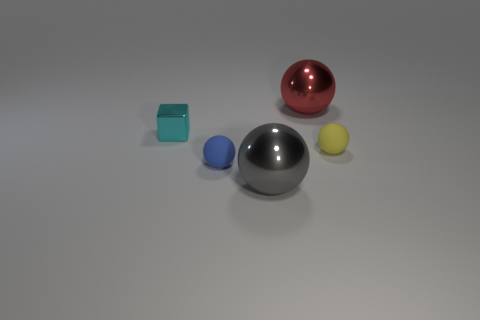Subtract all gray metal spheres. How many spheres are left? 3 Add 1 tiny metal things. How many objects exist? 6 Subtract all yellow spheres. How many spheres are left? 3 Subtract 1 balls. How many balls are left? 3 Subtract all balls. How many objects are left? 1 Subtract all green spheres. Subtract all gray blocks. How many spheres are left? 4 Add 3 red things. How many red things exist? 4 Subtract 0 green balls. How many objects are left? 5 Subtract all small cyan cubes. Subtract all cyan metal blocks. How many objects are left? 3 Add 1 tiny blue matte balls. How many tiny blue matte balls are left? 2 